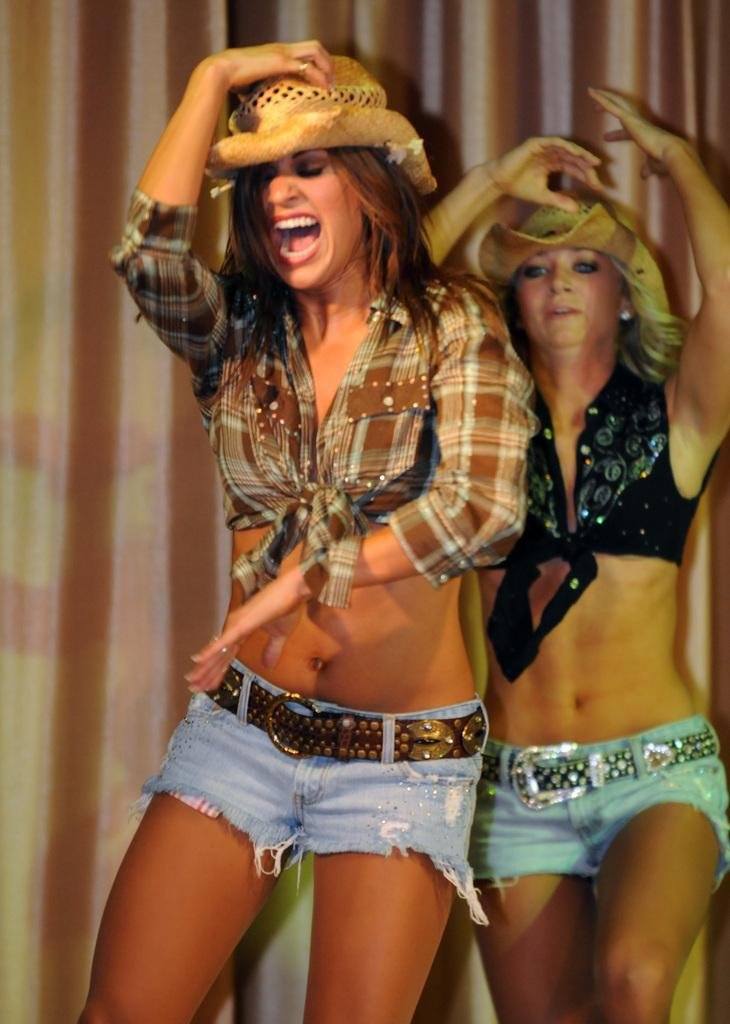How many women are present in the image? There are two women standing in the image. What are the women wearing on their heads? The women are wearing hats. What type of clothing are the women wearing on their lower bodies? The women are wearing shorts. What other types of clothing are the women wearing? The women are wearing other types of clothes, but the specific details are not mentioned in the facts. What can be seen in the background of the image? There are curtains in the background of the image. What type of potato is being held by one of the women in the image? There is no potato present in the image; the women are wearing hats and shorts, but no potato is mentioned or visible. 